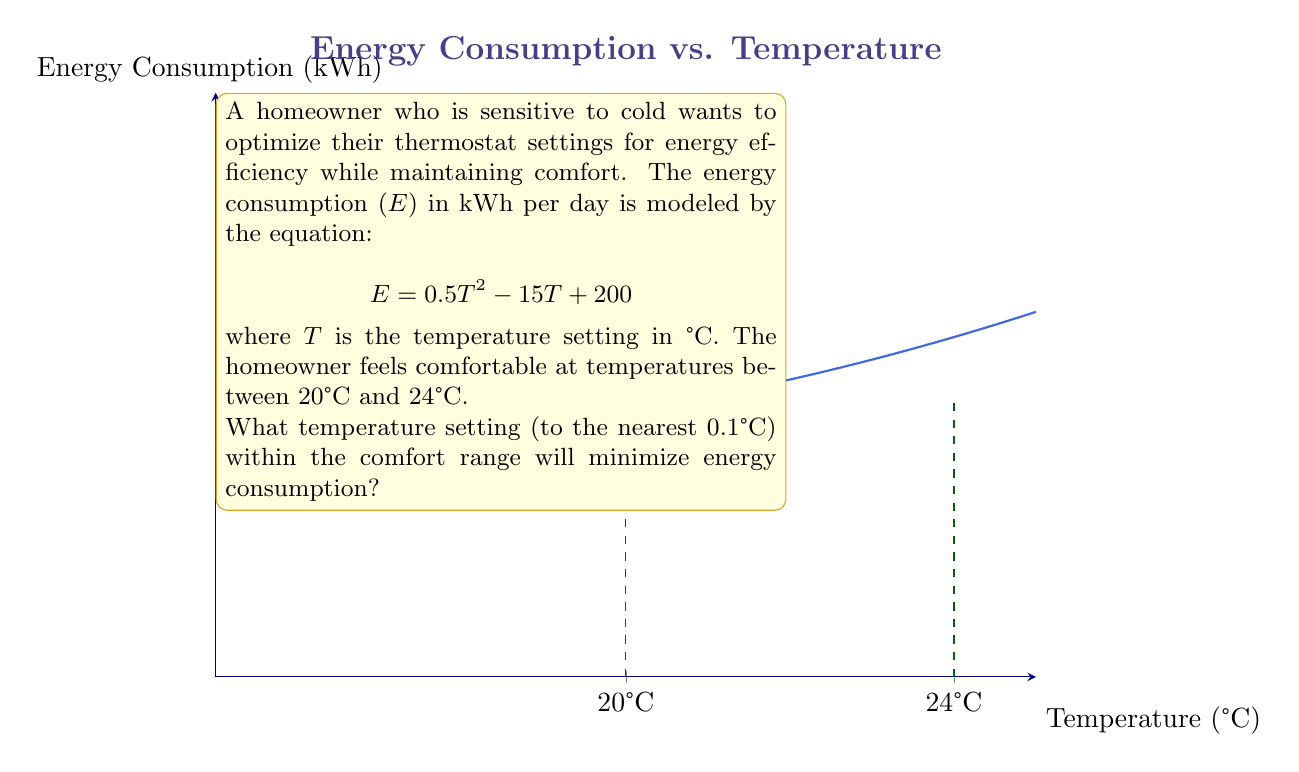Could you help me with this problem? To find the optimal temperature setting, we need to follow these steps:

1) The energy consumption function is a quadratic equation. The minimum point of a quadratic function occurs at the vertex of the parabola.

2) For a quadratic function in the form $f(x) = ax^2 + bx + c$, the x-coordinate of the vertex is given by $x = -\frac{b}{2a}$.

3) In our case, $a = 0.5$, $b = -15$, and $c = 200$. Let's calculate the x-coordinate of the vertex:

   $$T = -\frac{(-15)}{2(0.5)} = \frac{15}{1} = 15$$

4) However, 15°C is outside the comfort range of 20°C to 24°C.

5) Since the parabola opens upward (a > 0), the energy consumption will be minimized at the closest point to the vertex within the comfort range.

6) The closest point to 15°C within the range 20°C to 24°C is 20°C.

Therefore, the optimal temperature setting for energy efficiency within the comfort range is 20.0°C.
Answer: 20.0°C 